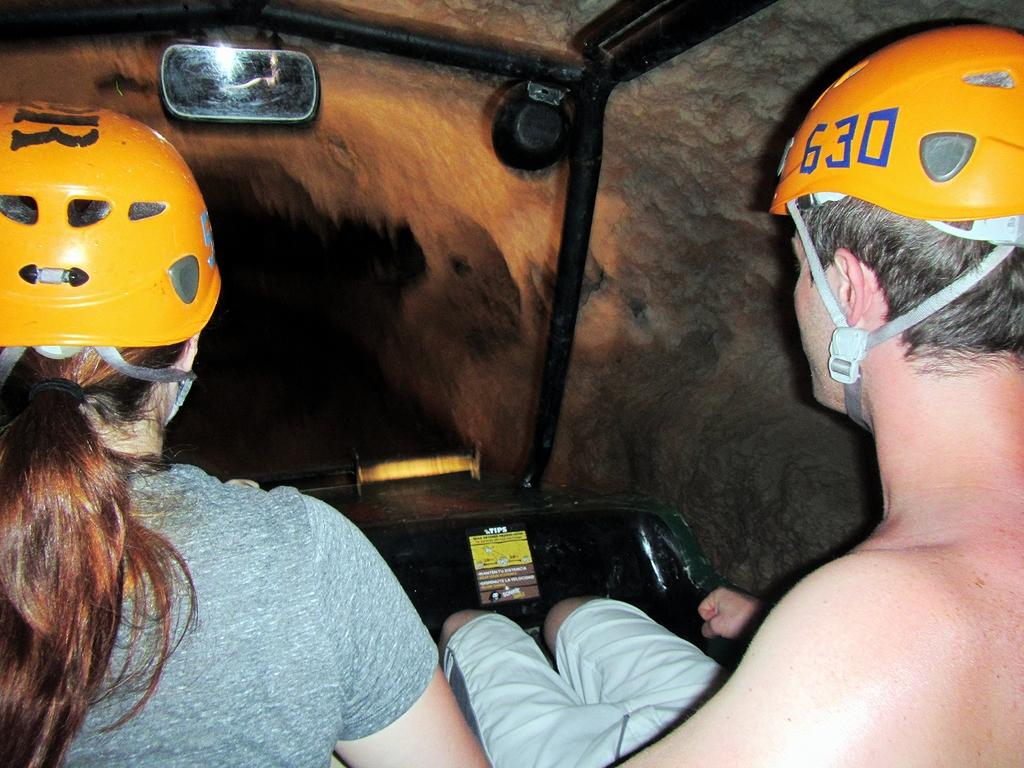How many people are in the image? There are two people in the image, a man and a woman. What are the man and woman wearing on their heads? Both the man and woman are wearing helmets. What type of vehicle are they in? They are present in a vehicle. Can you describe any additional features in the image? There is a mirror and a light visible in the image, and there are caves in the background. What type of playground equipment can be seen in the image? There is no playground equipment present in the image. Can you describe the coastline visible in the image? There is no coastline visible in the image; it features a vehicle with a man and woman wearing helmets, a mirror, a light, and caves in the background. 